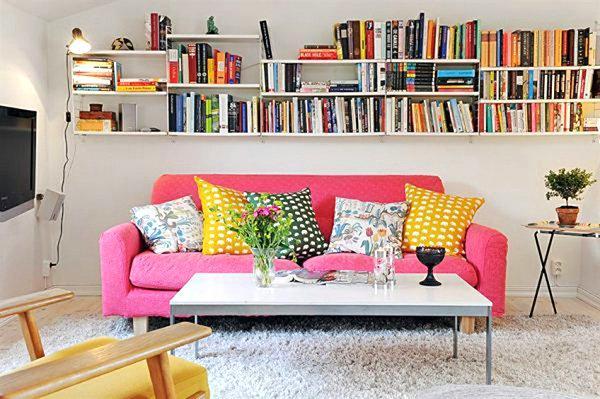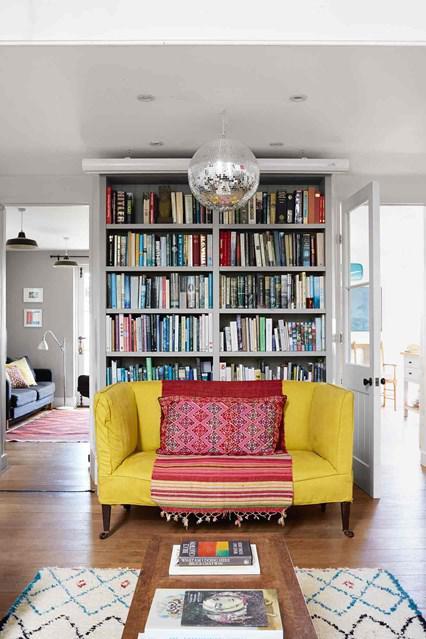The first image is the image on the left, the second image is the image on the right. Examine the images to the left and right. Is the description "There is a potted plant sitting on the floor in the image on the left." accurate? Answer yes or no. No. 